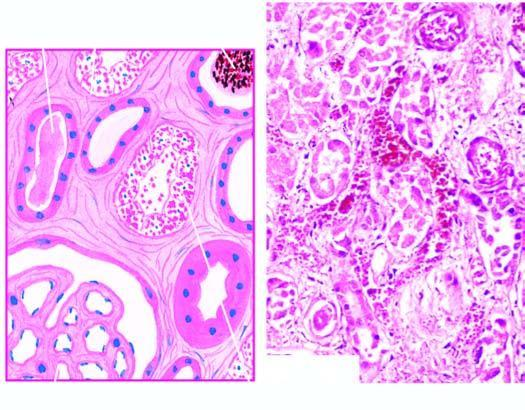re trophozoites of entamoeba histolytica dilated?
Answer the question using a single word or phrase. No 